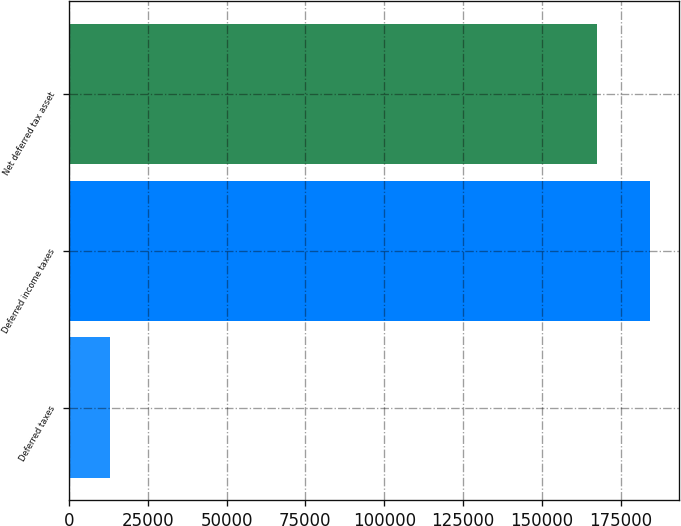Convert chart to OTSL. <chart><loc_0><loc_0><loc_500><loc_500><bar_chart><fcel>Deferred taxes<fcel>Deferred income taxes<fcel>Net deferred tax asset<nl><fcel>13039<fcel>184114<fcel>167376<nl></chart> 